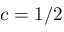<formula> <loc_0><loc_0><loc_500><loc_500>c = 1 / 2</formula> 